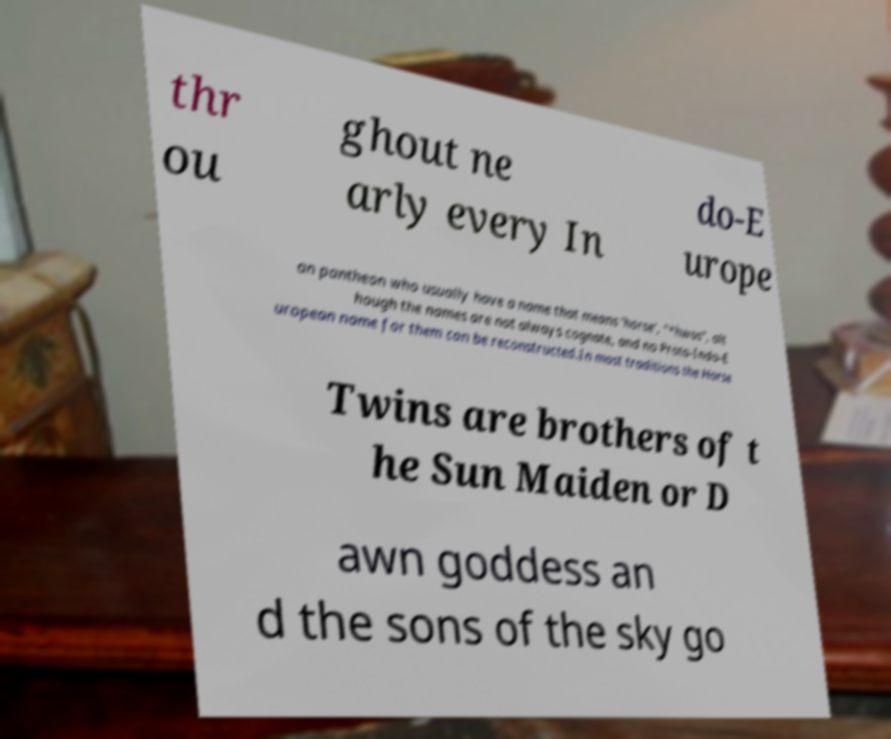What messages or text are displayed in this image? I need them in a readable, typed format. thr ou ghout ne arly every In do-E urope an pantheon who usually have a name that means 'horse', "*hwos", alt hough the names are not always cognate, and no Proto-Indo-E uropean name for them can be reconstructed.In most traditions the Horse Twins are brothers of t he Sun Maiden or D awn goddess an d the sons of the sky go 